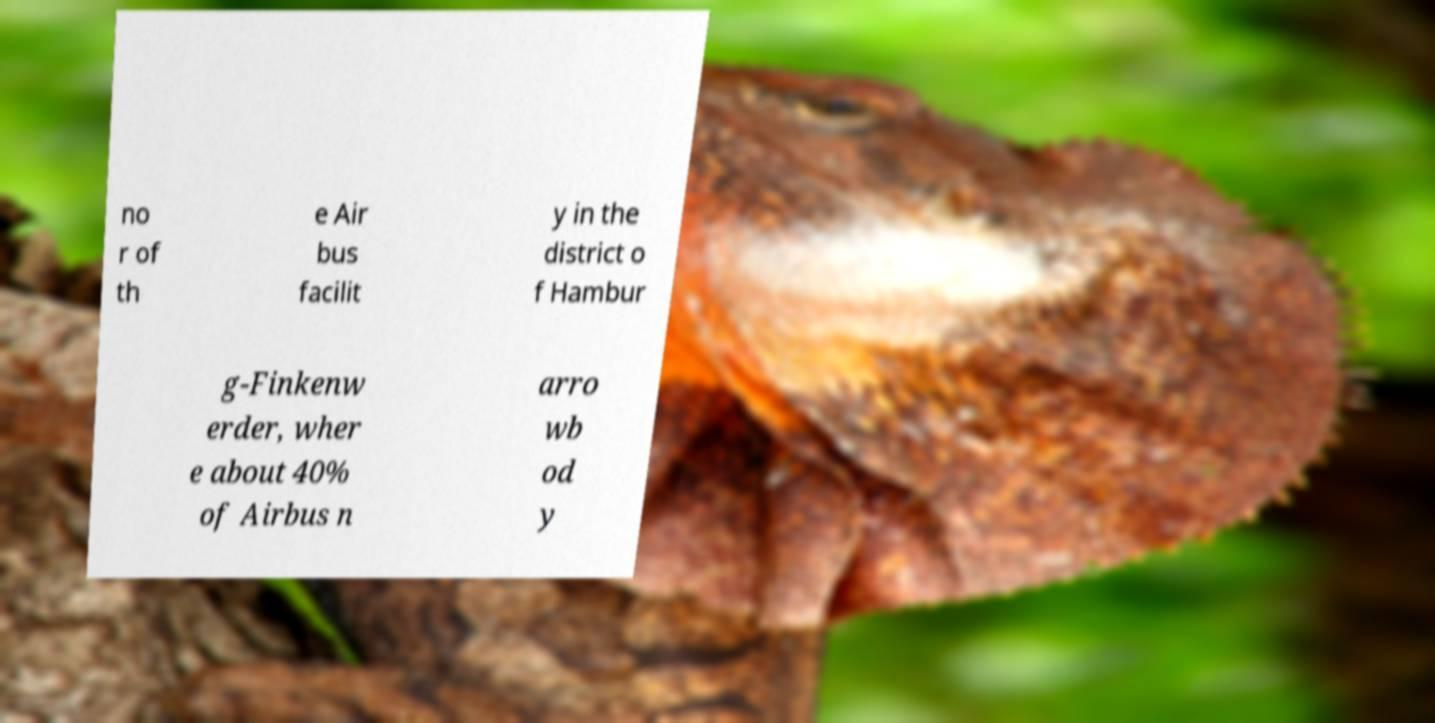Please identify and transcribe the text found in this image. no r of th e Air bus facilit y in the district o f Hambur g-Finkenw erder, wher e about 40% of Airbus n arro wb od y 